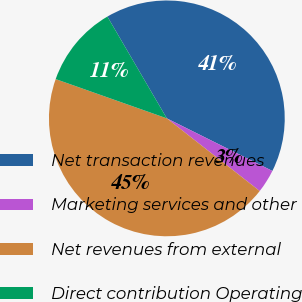<chart> <loc_0><loc_0><loc_500><loc_500><pie_chart><fcel>Net transaction revenues<fcel>Marketing services and other<fcel>Net revenues from external<fcel>Direct contribution Operating<nl><fcel>40.77%<fcel>3.21%<fcel>44.84%<fcel>11.18%<nl></chart> 